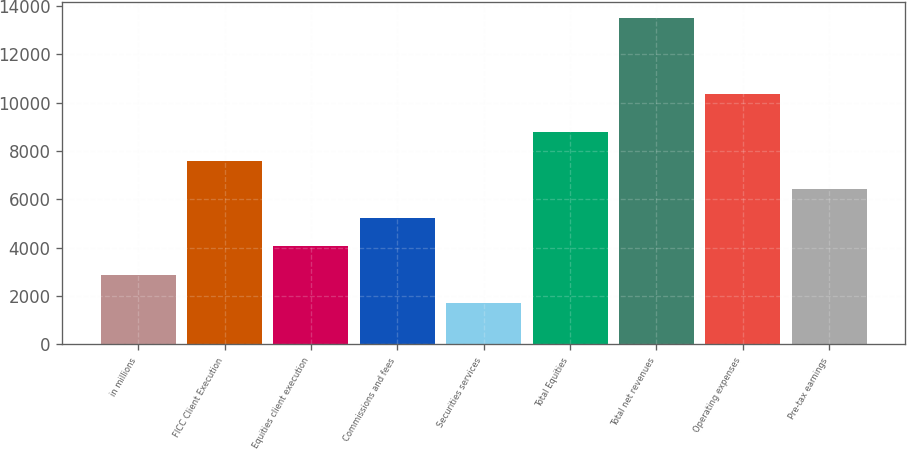Convert chart to OTSL. <chart><loc_0><loc_0><loc_500><loc_500><bar_chart><fcel>in millions<fcel>FICC Client Execution<fcel>Equities client execution<fcel>Commissions and fees<fcel>Securities services<fcel>Total Equities<fcel>Total net revenues<fcel>Operating expenses<fcel>Pre-tax earnings<nl><fcel>2887.2<fcel>7596<fcel>4064.4<fcel>5241.6<fcel>1710<fcel>8773.2<fcel>13482<fcel>10351<fcel>6418.8<nl></chart> 